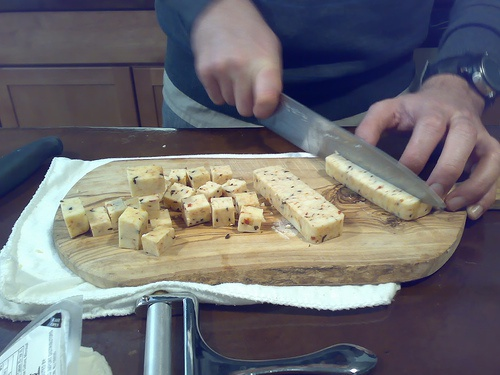Describe the objects in this image and their specific colors. I can see dining table in navy, ivory, darkgray, black, and tan tones, people in navy, darkgray, gray, and darkblue tones, knife in navy and gray tones, and cake in navy, tan, beige, and gray tones in this image. 